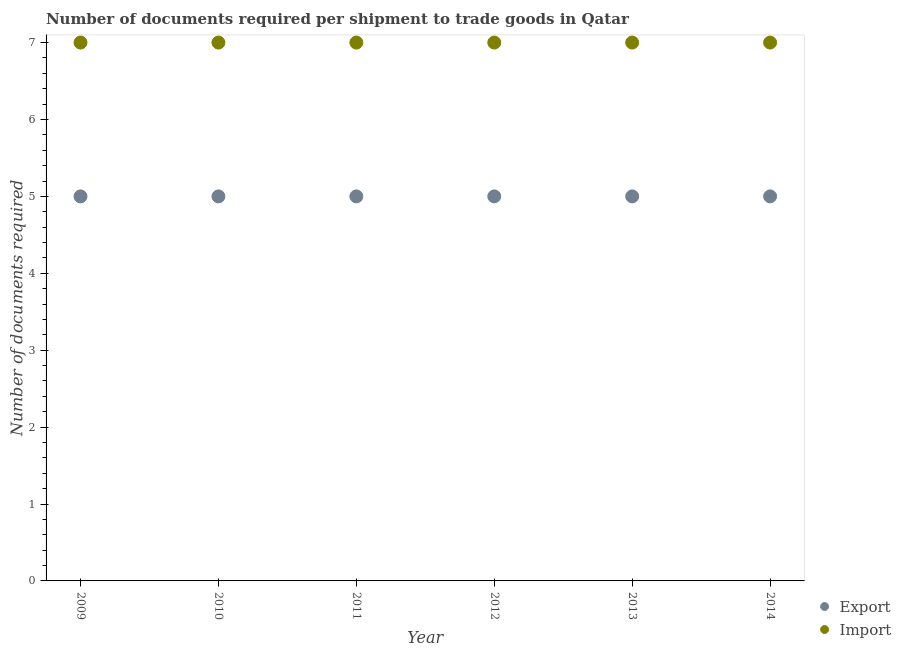How many different coloured dotlines are there?
Provide a short and direct response. 2. What is the number of documents required to import goods in 2010?
Keep it short and to the point. 7. Across all years, what is the maximum number of documents required to import goods?
Provide a succinct answer. 7. Across all years, what is the minimum number of documents required to export goods?
Offer a terse response. 5. In which year was the number of documents required to export goods maximum?
Ensure brevity in your answer.  2009. What is the total number of documents required to import goods in the graph?
Give a very brief answer. 42. What is the difference between the number of documents required to export goods in 2009 and that in 2011?
Make the answer very short. 0. What is the difference between the number of documents required to import goods in 2011 and the number of documents required to export goods in 2014?
Your answer should be compact. 2. In the year 2009, what is the difference between the number of documents required to import goods and number of documents required to export goods?
Provide a succinct answer. 2. Is the number of documents required to import goods in 2010 less than that in 2012?
Offer a terse response. No. What is the difference between the highest and the second highest number of documents required to import goods?
Your answer should be very brief. 0. What is the difference between the highest and the lowest number of documents required to export goods?
Make the answer very short. 0. Is the sum of the number of documents required to export goods in 2010 and 2012 greater than the maximum number of documents required to import goods across all years?
Offer a very short reply. Yes. Does the number of documents required to import goods monotonically increase over the years?
Ensure brevity in your answer.  No. Is the number of documents required to import goods strictly greater than the number of documents required to export goods over the years?
Your answer should be compact. Yes. How many years are there in the graph?
Provide a short and direct response. 6. Are the values on the major ticks of Y-axis written in scientific E-notation?
Give a very brief answer. No. Does the graph contain any zero values?
Make the answer very short. No. Where does the legend appear in the graph?
Offer a very short reply. Bottom right. What is the title of the graph?
Your response must be concise. Number of documents required per shipment to trade goods in Qatar. What is the label or title of the X-axis?
Your answer should be very brief. Year. What is the label or title of the Y-axis?
Provide a succinct answer. Number of documents required. What is the Number of documents required in Export in 2009?
Provide a short and direct response. 5. What is the Number of documents required of Import in 2009?
Give a very brief answer. 7. What is the Number of documents required in Export in 2010?
Keep it short and to the point. 5. What is the Number of documents required in Export in 2012?
Give a very brief answer. 5. What is the Number of documents required of Import in 2012?
Offer a very short reply. 7. What is the Number of documents required of Export in 2013?
Offer a very short reply. 5. Across all years, what is the maximum Number of documents required of Import?
Keep it short and to the point. 7. What is the difference between the Number of documents required in Import in 2009 and that in 2010?
Provide a succinct answer. 0. What is the difference between the Number of documents required of Import in 2009 and that in 2014?
Offer a very short reply. 0. What is the difference between the Number of documents required in Import in 2010 and that in 2011?
Your answer should be very brief. 0. What is the difference between the Number of documents required in Export in 2010 and that in 2014?
Offer a terse response. 0. What is the difference between the Number of documents required in Import in 2010 and that in 2014?
Your answer should be very brief. 0. What is the difference between the Number of documents required of Export in 2011 and that in 2012?
Provide a succinct answer. 0. What is the difference between the Number of documents required in Import in 2011 and that in 2013?
Keep it short and to the point. 0. What is the difference between the Number of documents required in Import in 2011 and that in 2014?
Offer a terse response. 0. What is the difference between the Number of documents required in Import in 2012 and that in 2014?
Offer a very short reply. 0. What is the difference between the Number of documents required in Export in 2013 and that in 2014?
Your response must be concise. 0. What is the difference between the Number of documents required of Export in 2009 and the Number of documents required of Import in 2010?
Offer a terse response. -2. What is the difference between the Number of documents required in Export in 2009 and the Number of documents required in Import in 2011?
Keep it short and to the point. -2. What is the difference between the Number of documents required in Export in 2009 and the Number of documents required in Import in 2014?
Make the answer very short. -2. What is the difference between the Number of documents required of Export in 2011 and the Number of documents required of Import in 2014?
Your response must be concise. -2. What is the difference between the Number of documents required in Export in 2012 and the Number of documents required in Import in 2013?
Your response must be concise. -2. What is the difference between the Number of documents required of Export in 2013 and the Number of documents required of Import in 2014?
Your answer should be compact. -2. What is the average Number of documents required of Export per year?
Your answer should be very brief. 5. What is the average Number of documents required in Import per year?
Your response must be concise. 7. In the year 2012, what is the difference between the Number of documents required of Export and Number of documents required of Import?
Provide a short and direct response. -2. In the year 2013, what is the difference between the Number of documents required in Export and Number of documents required in Import?
Your answer should be compact. -2. What is the ratio of the Number of documents required in Export in 2009 to that in 2010?
Your answer should be compact. 1. What is the ratio of the Number of documents required in Import in 2009 to that in 2010?
Give a very brief answer. 1. What is the ratio of the Number of documents required of Export in 2009 to that in 2011?
Your answer should be compact. 1. What is the ratio of the Number of documents required in Import in 2009 to that in 2011?
Keep it short and to the point. 1. What is the ratio of the Number of documents required of Export in 2009 to that in 2012?
Your answer should be compact. 1. What is the ratio of the Number of documents required of Import in 2009 to that in 2012?
Make the answer very short. 1. What is the ratio of the Number of documents required in Export in 2009 to that in 2014?
Your response must be concise. 1. What is the ratio of the Number of documents required of Import in 2009 to that in 2014?
Your answer should be very brief. 1. What is the ratio of the Number of documents required of Export in 2010 to that in 2011?
Give a very brief answer. 1. What is the ratio of the Number of documents required in Export in 2010 to that in 2012?
Provide a short and direct response. 1. What is the ratio of the Number of documents required of Import in 2010 to that in 2014?
Provide a succinct answer. 1. What is the ratio of the Number of documents required of Import in 2011 to that in 2012?
Offer a terse response. 1. What is the ratio of the Number of documents required of Import in 2012 to that in 2014?
Your answer should be very brief. 1. What is the difference between the highest and the second highest Number of documents required of Export?
Give a very brief answer. 0. What is the difference between the highest and the lowest Number of documents required in Import?
Your answer should be very brief. 0. 